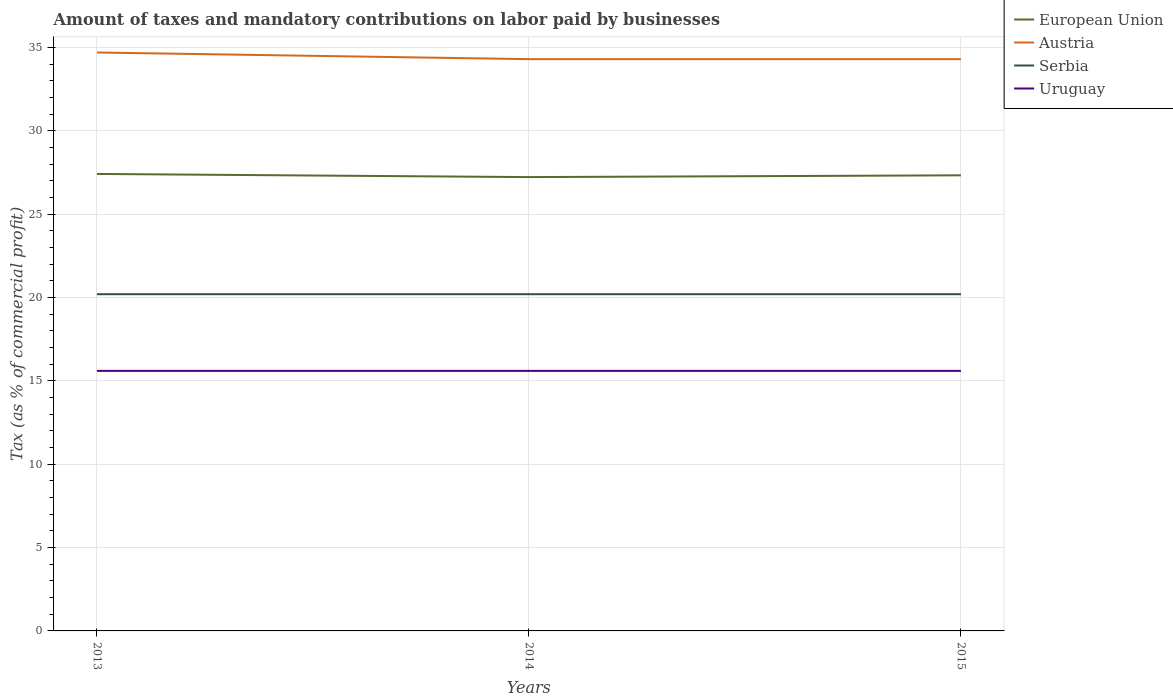Does the line corresponding to European Union intersect with the line corresponding to Austria?
Ensure brevity in your answer.  No. Across all years, what is the maximum percentage of taxes paid by businesses in Austria?
Provide a succinct answer. 34.3. In which year was the percentage of taxes paid by businesses in Uruguay maximum?
Give a very brief answer. 2013. What is the total percentage of taxes paid by businesses in Uruguay in the graph?
Your answer should be compact. 0. How are the legend labels stacked?
Provide a succinct answer. Vertical. What is the title of the graph?
Your response must be concise. Amount of taxes and mandatory contributions on labor paid by businesses. What is the label or title of the X-axis?
Ensure brevity in your answer.  Years. What is the label or title of the Y-axis?
Offer a terse response. Tax (as % of commercial profit). What is the Tax (as % of commercial profit) in European Union in 2013?
Ensure brevity in your answer.  27.41. What is the Tax (as % of commercial profit) of Austria in 2013?
Your answer should be compact. 34.7. What is the Tax (as % of commercial profit) in Serbia in 2013?
Offer a very short reply. 20.2. What is the Tax (as % of commercial profit) in Uruguay in 2013?
Your answer should be compact. 15.6. What is the Tax (as % of commercial profit) in European Union in 2014?
Ensure brevity in your answer.  27.23. What is the Tax (as % of commercial profit) in Austria in 2014?
Offer a very short reply. 34.3. What is the Tax (as % of commercial profit) of Serbia in 2014?
Provide a short and direct response. 20.2. What is the Tax (as % of commercial profit) in Uruguay in 2014?
Provide a short and direct response. 15.6. What is the Tax (as % of commercial profit) in European Union in 2015?
Give a very brief answer. 27.33. What is the Tax (as % of commercial profit) of Austria in 2015?
Provide a succinct answer. 34.3. What is the Tax (as % of commercial profit) in Serbia in 2015?
Provide a succinct answer. 20.2. Across all years, what is the maximum Tax (as % of commercial profit) of European Union?
Provide a succinct answer. 27.41. Across all years, what is the maximum Tax (as % of commercial profit) in Austria?
Make the answer very short. 34.7. Across all years, what is the maximum Tax (as % of commercial profit) in Serbia?
Your response must be concise. 20.2. Across all years, what is the minimum Tax (as % of commercial profit) in European Union?
Provide a short and direct response. 27.23. Across all years, what is the minimum Tax (as % of commercial profit) of Austria?
Give a very brief answer. 34.3. Across all years, what is the minimum Tax (as % of commercial profit) of Serbia?
Your answer should be compact. 20.2. Across all years, what is the minimum Tax (as % of commercial profit) in Uruguay?
Offer a very short reply. 15.6. What is the total Tax (as % of commercial profit) in European Union in the graph?
Your answer should be compact. 81.97. What is the total Tax (as % of commercial profit) in Austria in the graph?
Give a very brief answer. 103.3. What is the total Tax (as % of commercial profit) of Serbia in the graph?
Provide a succinct answer. 60.6. What is the total Tax (as % of commercial profit) in Uruguay in the graph?
Your answer should be very brief. 46.8. What is the difference between the Tax (as % of commercial profit) of European Union in 2013 and that in 2014?
Provide a succinct answer. 0.19. What is the difference between the Tax (as % of commercial profit) in Uruguay in 2013 and that in 2014?
Give a very brief answer. 0. What is the difference between the Tax (as % of commercial profit) of European Union in 2013 and that in 2015?
Your answer should be very brief. 0.08. What is the difference between the Tax (as % of commercial profit) of Serbia in 2013 and that in 2015?
Make the answer very short. 0. What is the difference between the Tax (as % of commercial profit) in Uruguay in 2013 and that in 2015?
Keep it short and to the point. 0. What is the difference between the Tax (as % of commercial profit) of European Union in 2014 and that in 2015?
Provide a short and direct response. -0.11. What is the difference between the Tax (as % of commercial profit) of Serbia in 2014 and that in 2015?
Make the answer very short. 0. What is the difference between the Tax (as % of commercial profit) in European Union in 2013 and the Tax (as % of commercial profit) in Austria in 2014?
Give a very brief answer. -6.89. What is the difference between the Tax (as % of commercial profit) of European Union in 2013 and the Tax (as % of commercial profit) of Serbia in 2014?
Keep it short and to the point. 7.21. What is the difference between the Tax (as % of commercial profit) of European Union in 2013 and the Tax (as % of commercial profit) of Uruguay in 2014?
Keep it short and to the point. 11.81. What is the difference between the Tax (as % of commercial profit) of Austria in 2013 and the Tax (as % of commercial profit) of Uruguay in 2014?
Your answer should be compact. 19.1. What is the difference between the Tax (as % of commercial profit) of Serbia in 2013 and the Tax (as % of commercial profit) of Uruguay in 2014?
Make the answer very short. 4.6. What is the difference between the Tax (as % of commercial profit) of European Union in 2013 and the Tax (as % of commercial profit) of Austria in 2015?
Your answer should be very brief. -6.89. What is the difference between the Tax (as % of commercial profit) of European Union in 2013 and the Tax (as % of commercial profit) of Serbia in 2015?
Your answer should be very brief. 7.21. What is the difference between the Tax (as % of commercial profit) of European Union in 2013 and the Tax (as % of commercial profit) of Uruguay in 2015?
Offer a very short reply. 11.81. What is the difference between the Tax (as % of commercial profit) of Austria in 2013 and the Tax (as % of commercial profit) of Uruguay in 2015?
Your answer should be compact. 19.1. What is the difference between the Tax (as % of commercial profit) of European Union in 2014 and the Tax (as % of commercial profit) of Austria in 2015?
Keep it short and to the point. -7.08. What is the difference between the Tax (as % of commercial profit) in European Union in 2014 and the Tax (as % of commercial profit) in Serbia in 2015?
Offer a terse response. 7.03. What is the difference between the Tax (as % of commercial profit) in European Union in 2014 and the Tax (as % of commercial profit) in Uruguay in 2015?
Give a very brief answer. 11.62. What is the difference between the Tax (as % of commercial profit) in Austria in 2014 and the Tax (as % of commercial profit) in Serbia in 2015?
Make the answer very short. 14.1. What is the difference between the Tax (as % of commercial profit) of Austria in 2014 and the Tax (as % of commercial profit) of Uruguay in 2015?
Provide a succinct answer. 18.7. What is the difference between the Tax (as % of commercial profit) in Serbia in 2014 and the Tax (as % of commercial profit) in Uruguay in 2015?
Your answer should be very brief. 4.6. What is the average Tax (as % of commercial profit) of European Union per year?
Make the answer very short. 27.32. What is the average Tax (as % of commercial profit) in Austria per year?
Provide a succinct answer. 34.43. What is the average Tax (as % of commercial profit) in Serbia per year?
Your answer should be compact. 20.2. What is the average Tax (as % of commercial profit) of Uruguay per year?
Make the answer very short. 15.6. In the year 2013, what is the difference between the Tax (as % of commercial profit) of European Union and Tax (as % of commercial profit) of Austria?
Keep it short and to the point. -7.29. In the year 2013, what is the difference between the Tax (as % of commercial profit) of European Union and Tax (as % of commercial profit) of Serbia?
Give a very brief answer. 7.21. In the year 2013, what is the difference between the Tax (as % of commercial profit) in European Union and Tax (as % of commercial profit) in Uruguay?
Keep it short and to the point. 11.81. In the year 2013, what is the difference between the Tax (as % of commercial profit) of Austria and Tax (as % of commercial profit) of Uruguay?
Provide a succinct answer. 19.1. In the year 2014, what is the difference between the Tax (as % of commercial profit) in European Union and Tax (as % of commercial profit) in Austria?
Offer a terse response. -7.08. In the year 2014, what is the difference between the Tax (as % of commercial profit) of European Union and Tax (as % of commercial profit) of Serbia?
Your answer should be very brief. 7.03. In the year 2014, what is the difference between the Tax (as % of commercial profit) of European Union and Tax (as % of commercial profit) of Uruguay?
Provide a succinct answer. 11.62. In the year 2014, what is the difference between the Tax (as % of commercial profit) in Austria and Tax (as % of commercial profit) in Serbia?
Give a very brief answer. 14.1. In the year 2014, what is the difference between the Tax (as % of commercial profit) in Serbia and Tax (as % of commercial profit) in Uruguay?
Give a very brief answer. 4.6. In the year 2015, what is the difference between the Tax (as % of commercial profit) in European Union and Tax (as % of commercial profit) in Austria?
Offer a very short reply. -6.97. In the year 2015, what is the difference between the Tax (as % of commercial profit) of European Union and Tax (as % of commercial profit) of Serbia?
Ensure brevity in your answer.  7.13. In the year 2015, what is the difference between the Tax (as % of commercial profit) of European Union and Tax (as % of commercial profit) of Uruguay?
Keep it short and to the point. 11.73. In the year 2015, what is the difference between the Tax (as % of commercial profit) of Austria and Tax (as % of commercial profit) of Uruguay?
Provide a short and direct response. 18.7. In the year 2015, what is the difference between the Tax (as % of commercial profit) in Serbia and Tax (as % of commercial profit) in Uruguay?
Your response must be concise. 4.6. What is the ratio of the Tax (as % of commercial profit) of Austria in 2013 to that in 2014?
Keep it short and to the point. 1.01. What is the ratio of the Tax (as % of commercial profit) in Uruguay in 2013 to that in 2014?
Provide a short and direct response. 1. What is the ratio of the Tax (as % of commercial profit) of European Union in 2013 to that in 2015?
Make the answer very short. 1. What is the ratio of the Tax (as % of commercial profit) in Austria in 2013 to that in 2015?
Provide a short and direct response. 1.01. What is the ratio of the Tax (as % of commercial profit) of Serbia in 2013 to that in 2015?
Offer a terse response. 1. What is the ratio of the Tax (as % of commercial profit) of Uruguay in 2013 to that in 2015?
Provide a short and direct response. 1. What is the ratio of the Tax (as % of commercial profit) in European Union in 2014 to that in 2015?
Provide a succinct answer. 1. What is the ratio of the Tax (as % of commercial profit) of Serbia in 2014 to that in 2015?
Offer a very short reply. 1. What is the ratio of the Tax (as % of commercial profit) of Uruguay in 2014 to that in 2015?
Make the answer very short. 1. What is the difference between the highest and the second highest Tax (as % of commercial profit) in European Union?
Give a very brief answer. 0.08. What is the difference between the highest and the second highest Tax (as % of commercial profit) of Austria?
Your response must be concise. 0.4. What is the difference between the highest and the second highest Tax (as % of commercial profit) of Serbia?
Your answer should be compact. 0. What is the difference between the highest and the second highest Tax (as % of commercial profit) in Uruguay?
Ensure brevity in your answer.  0. What is the difference between the highest and the lowest Tax (as % of commercial profit) of European Union?
Your answer should be very brief. 0.19. What is the difference between the highest and the lowest Tax (as % of commercial profit) in Serbia?
Make the answer very short. 0. What is the difference between the highest and the lowest Tax (as % of commercial profit) in Uruguay?
Your answer should be compact. 0. 